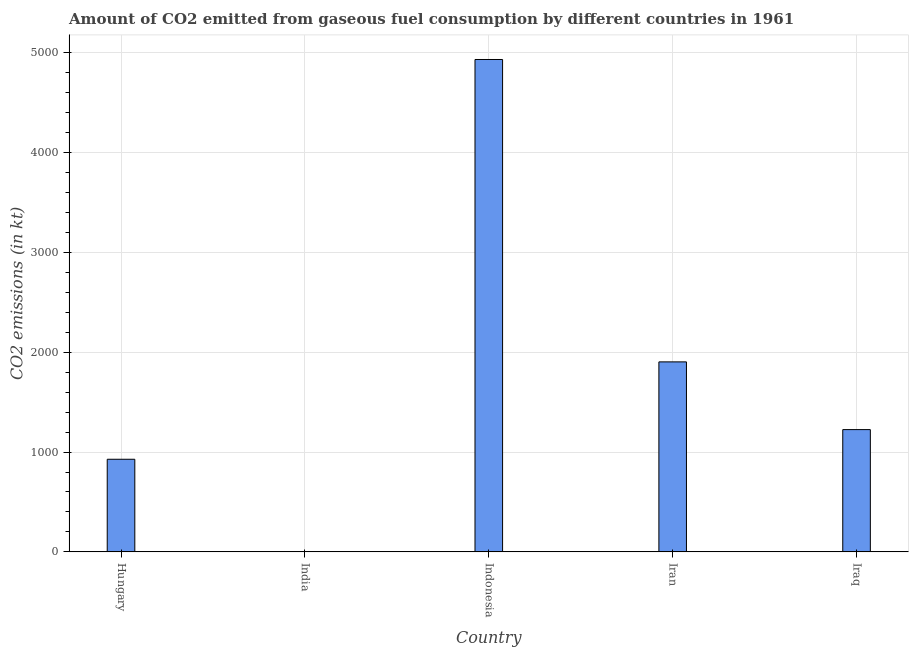Does the graph contain any zero values?
Offer a terse response. No. Does the graph contain grids?
Offer a very short reply. Yes. What is the title of the graph?
Offer a very short reply. Amount of CO2 emitted from gaseous fuel consumption by different countries in 1961. What is the label or title of the X-axis?
Ensure brevity in your answer.  Country. What is the label or title of the Y-axis?
Ensure brevity in your answer.  CO2 emissions (in kt). What is the co2 emissions from gaseous fuel consumption in Iraq?
Your answer should be very brief. 1224.78. Across all countries, what is the maximum co2 emissions from gaseous fuel consumption?
Offer a terse response. 4932.11. Across all countries, what is the minimum co2 emissions from gaseous fuel consumption?
Ensure brevity in your answer.  3.67. In which country was the co2 emissions from gaseous fuel consumption maximum?
Ensure brevity in your answer.  Indonesia. What is the sum of the co2 emissions from gaseous fuel consumption?
Provide a succinct answer. 8991.48. What is the difference between the co2 emissions from gaseous fuel consumption in Iran and Iraq?
Your response must be concise. 678.39. What is the average co2 emissions from gaseous fuel consumption per country?
Provide a short and direct response. 1798.3. What is the median co2 emissions from gaseous fuel consumption?
Give a very brief answer. 1224.78. In how many countries, is the co2 emissions from gaseous fuel consumption greater than 3200 kt?
Make the answer very short. 1. What is the ratio of the co2 emissions from gaseous fuel consumption in Iran to that in Iraq?
Offer a very short reply. 1.55. Is the co2 emissions from gaseous fuel consumption in India less than that in Iran?
Offer a terse response. Yes. Is the difference between the co2 emissions from gaseous fuel consumption in India and Iraq greater than the difference between any two countries?
Keep it short and to the point. No. What is the difference between the highest and the second highest co2 emissions from gaseous fuel consumption?
Provide a succinct answer. 3028.94. What is the difference between the highest and the lowest co2 emissions from gaseous fuel consumption?
Ensure brevity in your answer.  4928.45. Are all the bars in the graph horizontal?
Provide a succinct answer. No. Are the values on the major ticks of Y-axis written in scientific E-notation?
Your answer should be very brief. No. What is the CO2 emissions (in kt) in Hungary?
Offer a very short reply. 927.75. What is the CO2 emissions (in kt) in India?
Ensure brevity in your answer.  3.67. What is the CO2 emissions (in kt) of Indonesia?
Your answer should be very brief. 4932.11. What is the CO2 emissions (in kt) of Iran?
Offer a terse response. 1903.17. What is the CO2 emissions (in kt) of Iraq?
Offer a very short reply. 1224.78. What is the difference between the CO2 emissions (in kt) in Hungary and India?
Your answer should be very brief. 924.08. What is the difference between the CO2 emissions (in kt) in Hungary and Indonesia?
Give a very brief answer. -4004.36. What is the difference between the CO2 emissions (in kt) in Hungary and Iran?
Make the answer very short. -975.42. What is the difference between the CO2 emissions (in kt) in Hungary and Iraq?
Your answer should be compact. -297.03. What is the difference between the CO2 emissions (in kt) in India and Indonesia?
Your answer should be compact. -4928.45. What is the difference between the CO2 emissions (in kt) in India and Iran?
Give a very brief answer. -1899.51. What is the difference between the CO2 emissions (in kt) in India and Iraq?
Provide a short and direct response. -1221.11. What is the difference between the CO2 emissions (in kt) in Indonesia and Iran?
Offer a very short reply. 3028.94. What is the difference between the CO2 emissions (in kt) in Indonesia and Iraq?
Offer a very short reply. 3707.34. What is the difference between the CO2 emissions (in kt) in Iran and Iraq?
Keep it short and to the point. 678.39. What is the ratio of the CO2 emissions (in kt) in Hungary to that in India?
Give a very brief answer. 253. What is the ratio of the CO2 emissions (in kt) in Hungary to that in Indonesia?
Provide a short and direct response. 0.19. What is the ratio of the CO2 emissions (in kt) in Hungary to that in Iran?
Provide a succinct answer. 0.49. What is the ratio of the CO2 emissions (in kt) in Hungary to that in Iraq?
Your answer should be very brief. 0.76. What is the ratio of the CO2 emissions (in kt) in India to that in Iran?
Provide a succinct answer. 0. What is the ratio of the CO2 emissions (in kt) in India to that in Iraq?
Give a very brief answer. 0. What is the ratio of the CO2 emissions (in kt) in Indonesia to that in Iran?
Make the answer very short. 2.59. What is the ratio of the CO2 emissions (in kt) in Indonesia to that in Iraq?
Offer a terse response. 4.03. What is the ratio of the CO2 emissions (in kt) in Iran to that in Iraq?
Give a very brief answer. 1.55. 